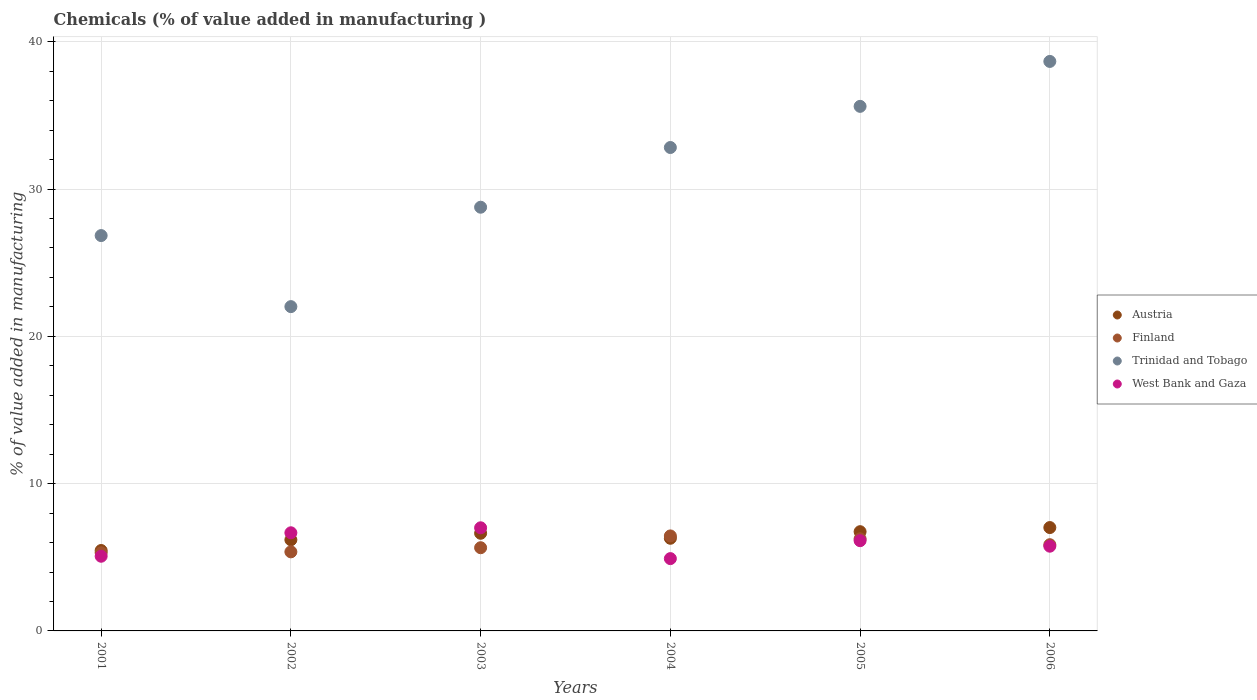How many different coloured dotlines are there?
Your answer should be very brief. 4. What is the value added in manufacturing chemicals in Finland in 2004?
Provide a succinct answer. 6.45. Across all years, what is the maximum value added in manufacturing chemicals in Finland?
Give a very brief answer. 6.45. Across all years, what is the minimum value added in manufacturing chemicals in Trinidad and Tobago?
Offer a terse response. 22.02. In which year was the value added in manufacturing chemicals in Austria maximum?
Ensure brevity in your answer.  2006. What is the total value added in manufacturing chemicals in Trinidad and Tobago in the graph?
Offer a terse response. 184.73. What is the difference between the value added in manufacturing chemicals in Austria in 2003 and that in 2006?
Keep it short and to the point. -0.39. What is the difference between the value added in manufacturing chemicals in Finland in 2005 and the value added in manufacturing chemicals in Austria in 2001?
Provide a succinct answer. 0.79. What is the average value added in manufacturing chemicals in West Bank and Gaza per year?
Keep it short and to the point. 5.92. In the year 2002, what is the difference between the value added in manufacturing chemicals in Trinidad and Tobago and value added in manufacturing chemicals in West Bank and Gaza?
Give a very brief answer. 15.36. In how many years, is the value added in manufacturing chemicals in Austria greater than 14 %?
Offer a very short reply. 0. What is the ratio of the value added in manufacturing chemicals in West Bank and Gaza in 2004 to that in 2006?
Your answer should be very brief. 0.85. What is the difference between the highest and the second highest value added in manufacturing chemicals in Finland?
Give a very brief answer. 0.2. What is the difference between the highest and the lowest value added in manufacturing chemicals in Austria?
Your answer should be compact. 1.56. In how many years, is the value added in manufacturing chemicals in Austria greater than the average value added in manufacturing chemicals in Austria taken over all years?
Offer a very short reply. 3. Is it the case that in every year, the sum of the value added in manufacturing chemicals in Trinidad and Tobago and value added in manufacturing chemicals in West Bank and Gaza  is greater than the value added in manufacturing chemicals in Finland?
Make the answer very short. Yes. Does the value added in manufacturing chemicals in Trinidad and Tobago monotonically increase over the years?
Your answer should be compact. No. Are the values on the major ticks of Y-axis written in scientific E-notation?
Give a very brief answer. No. How many legend labels are there?
Ensure brevity in your answer.  4. How are the legend labels stacked?
Provide a succinct answer. Vertical. What is the title of the graph?
Keep it short and to the point. Chemicals (% of value added in manufacturing ). Does "Other small states" appear as one of the legend labels in the graph?
Give a very brief answer. No. What is the label or title of the X-axis?
Keep it short and to the point. Years. What is the label or title of the Y-axis?
Keep it short and to the point. % of value added in manufacturing. What is the % of value added in manufacturing in Austria in 2001?
Offer a terse response. 5.46. What is the % of value added in manufacturing in Finland in 2001?
Give a very brief answer. 5.3. What is the % of value added in manufacturing in Trinidad and Tobago in 2001?
Your answer should be very brief. 26.84. What is the % of value added in manufacturing of West Bank and Gaza in 2001?
Provide a succinct answer. 5.07. What is the % of value added in manufacturing of Austria in 2002?
Make the answer very short. 6.19. What is the % of value added in manufacturing of Finland in 2002?
Ensure brevity in your answer.  5.37. What is the % of value added in manufacturing of Trinidad and Tobago in 2002?
Your answer should be very brief. 22.02. What is the % of value added in manufacturing of West Bank and Gaza in 2002?
Offer a very short reply. 6.66. What is the % of value added in manufacturing of Austria in 2003?
Make the answer very short. 6.63. What is the % of value added in manufacturing of Finland in 2003?
Your response must be concise. 5.65. What is the % of value added in manufacturing in Trinidad and Tobago in 2003?
Ensure brevity in your answer.  28.77. What is the % of value added in manufacturing in West Bank and Gaza in 2003?
Keep it short and to the point. 7. What is the % of value added in manufacturing of Austria in 2004?
Your answer should be very brief. 6.29. What is the % of value added in manufacturing in Finland in 2004?
Your response must be concise. 6.45. What is the % of value added in manufacturing in Trinidad and Tobago in 2004?
Your answer should be very brief. 32.82. What is the % of value added in manufacturing of West Bank and Gaza in 2004?
Keep it short and to the point. 4.91. What is the % of value added in manufacturing of Austria in 2005?
Give a very brief answer. 6.74. What is the % of value added in manufacturing of Finland in 2005?
Provide a succinct answer. 6.25. What is the % of value added in manufacturing of Trinidad and Tobago in 2005?
Provide a succinct answer. 35.61. What is the % of value added in manufacturing in West Bank and Gaza in 2005?
Provide a succinct answer. 6.13. What is the % of value added in manufacturing of Austria in 2006?
Give a very brief answer. 7.02. What is the % of value added in manufacturing in Finland in 2006?
Keep it short and to the point. 5.85. What is the % of value added in manufacturing of Trinidad and Tobago in 2006?
Provide a short and direct response. 38.67. What is the % of value added in manufacturing in West Bank and Gaza in 2006?
Your response must be concise. 5.75. Across all years, what is the maximum % of value added in manufacturing of Austria?
Keep it short and to the point. 7.02. Across all years, what is the maximum % of value added in manufacturing in Finland?
Keep it short and to the point. 6.45. Across all years, what is the maximum % of value added in manufacturing of Trinidad and Tobago?
Keep it short and to the point. 38.67. Across all years, what is the maximum % of value added in manufacturing in West Bank and Gaza?
Provide a succinct answer. 7. Across all years, what is the minimum % of value added in manufacturing in Austria?
Your response must be concise. 5.46. Across all years, what is the minimum % of value added in manufacturing in Finland?
Offer a terse response. 5.3. Across all years, what is the minimum % of value added in manufacturing in Trinidad and Tobago?
Provide a short and direct response. 22.02. Across all years, what is the minimum % of value added in manufacturing in West Bank and Gaza?
Provide a short and direct response. 4.91. What is the total % of value added in manufacturing of Austria in the graph?
Your response must be concise. 38.32. What is the total % of value added in manufacturing in Finland in the graph?
Offer a very short reply. 34.88. What is the total % of value added in manufacturing in Trinidad and Tobago in the graph?
Ensure brevity in your answer.  184.73. What is the total % of value added in manufacturing of West Bank and Gaza in the graph?
Your answer should be very brief. 35.52. What is the difference between the % of value added in manufacturing in Austria in 2001 and that in 2002?
Your answer should be compact. -0.73. What is the difference between the % of value added in manufacturing in Finland in 2001 and that in 2002?
Offer a terse response. -0.06. What is the difference between the % of value added in manufacturing in Trinidad and Tobago in 2001 and that in 2002?
Your response must be concise. 4.82. What is the difference between the % of value added in manufacturing of West Bank and Gaza in 2001 and that in 2002?
Your answer should be very brief. -1.59. What is the difference between the % of value added in manufacturing in Austria in 2001 and that in 2003?
Give a very brief answer. -1.17. What is the difference between the % of value added in manufacturing of Finland in 2001 and that in 2003?
Provide a succinct answer. -0.34. What is the difference between the % of value added in manufacturing in Trinidad and Tobago in 2001 and that in 2003?
Keep it short and to the point. -1.93. What is the difference between the % of value added in manufacturing of West Bank and Gaza in 2001 and that in 2003?
Offer a very short reply. -1.93. What is the difference between the % of value added in manufacturing of Austria in 2001 and that in 2004?
Your answer should be very brief. -0.83. What is the difference between the % of value added in manufacturing of Finland in 2001 and that in 2004?
Give a very brief answer. -1.15. What is the difference between the % of value added in manufacturing of Trinidad and Tobago in 2001 and that in 2004?
Ensure brevity in your answer.  -5.98. What is the difference between the % of value added in manufacturing of West Bank and Gaza in 2001 and that in 2004?
Your answer should be compact. 0.16. What is the difference between the % of value added in manufacturing in Austria in 2001 and that in 2005?
Offer a very short reply. -1.28. What is the difference between the % of value added in manufacturing of Finland in 2001 and that in 2005?
Your response must be concise. -0.95. What is the difference between the % of value added in manufacturing of Trinidad and Tobago in 2001 and that in 2005?
Give a very brief answer. -8.77. What is the difference between the % of value added in manufacturing of West Bank and Gaza in 2001 and that in 2005?
Ensure brevity in your answer.  -1.06. What is the difference between the % of value added in manufacturing of Austria in 2001 and that in 2006?
Your response must be concise. -1.56. What is the difference between the % of value added in manufacturing of Finland in 2001 and that in 2006?
Your response must be concise. -0.55. What is the difference between the % of value added in manufacturing in Trinidad and Tobago in 2001 and that in 2006?
Your response must be concise. -11.82. What is the difference between the % of value added in manufacturing in West Bank and Gaza in 2001 and that in 2006?
Your response must be concise. -0.68. What is the difference between the % of value added in manufacturing of Austria in 2002 and that in 2003?
Your answer should be compact. -0.44. What is the difference between the % of value added in manufacturing in Finland in 2002 and that in 2003?
Ensure brevity in your answer.  -0.28. What is the difference between the % of value added in manufacturing of Trinidad and Tobago in 2002 and that in 2003?
Keep it short and to the point. -6.75. What is the difference between the % of value added in manufacturing in West Bank and Gaza in 2002 and that in 2003?
Your answer should be compact. -0.34. What is the difference between the % of value added in manufacturing in Austria in 2002 and that in 2004?
Make the answer very short. -0.1. What is the difference between the % of value added in manufacturing in Finland in 2002 and that in 2004?
Ensure brevity in your answer.  -1.08. What is the difference between the % of value added in manufacturing of Trinidad and Tobago in 2002 and that in 2004?
Your response must be concise. -10.8. What is the difference between the % of value added in manufacturing of West Bank and Gaza in 2002 and that in 2004?
Give a very brief answer. 1.75. What is the difference between the % of value added in manufacturing in Austria in 2002 and that in 2005?
Your answer should be very brief. -0.55. What is the difference between the % of value added in manufacturing of Finland in 2002 and that in 2005?
Ensure brevity in your answer.  -0.89. What is the difference between the % of value added in manufacturing in Trinidad and Tobago in 2002 and that in 2005?
Offer a terse response. -13.6. What is the difference between the % of value added in manufacturing in West Bank and Gaza in 2002 and that in 2005?
Your answer should be compact. 0.54. What is the difference between the % of value added in manufacturing in Austria in 2002 and that in 2006?
Provide a succinct answer. -0.83. What is the difference between the % of value added in manufacturing of Finland in 2002 and that in 2006?
Offer a terse response. -0.49. What is the difference between the % of value added in manufacturing of Trinidad and Tobago in 2002 and that in 2006?
Keep it short and to the point. -16.65. What is the difference between the % of value added in manufacturing of West Bank and Gaza in 2002 and that in 2006?
Ensure brevity in your answer.  0.91. What is the difference between the % of value added in manufacturing of Austria in 2003 and that in 2004?
Your answer should be compact. 0.34. What is the difference between the % of value added in manufacturing in Finland in 2003 and that in 2004?
Your response must be concise. -0.8. What is the difference between the % of value added in manufacturing in Trinidad and Tobago in 2003 and that in 2004?
Provide a succinct answer. -4.05. What is the difference between the % of value added in manufacturing in West Bank and Gaza in 2003 and that in 2004?
Keep it short and to the point. 2.09. What is the difference between the % of value added in manufacturing in Austria in 2003 and that in 2005?
Provide a succinct answer. -0.11. What is the difference between the % of value added in manufacturing of Finland in 2003 and that in 2005?
Ensure brevity in your answer.  -0.6. What is the difference between the % of value added in manufacturing in Trinidad and Tobago in 2003 and that in 2005?
Offer a very short reply. -6.85. What is the difference between the % of value added in manufacturing of West Bank and Gaza in 2003 and that in 2005?
Your response must be concise. 0.87. What is the difference between the % of value added in manufacturing of Austria in 2003 and that in 2006?
Your answer should be very brief. -0.39. What is the difference between the % of value added in manufacturing of Finland in 2003 and that in 2006?
Provide a succinct answer. -0.2. What is the difference between the % of value added in manufacturing of Trinidad and Tobago in 2003 and that in 2006?
Provide a short and direct response. -9.9. What is the difference between the % of value added in manufacturing of West Bank and Gaza in 2003 and that in 2006?
Your answer should be very brief. 1.25. What is the difference between the % of value added in manufacturing of Austria in 2004 and that in 2005?
Your answer should be compact. -0.45. What is the difference between the % of value added in manufacturing in Finland in 2004 and that in 2005?
Provide a succinct answer. 0.2. What is the difference between the % of value added in manufacturing in Trinidad and Tobago in 2004 and that in 2005?
Your answer should be very brief. -2.79. What is the difference between the % of value added in manufacturing in West Bank and Gaza in 2004 and that in 2005?
Offer a terse response. -1.22. What is the difference between the % of value added in manufacturing in Austria in 2004 and that in 2006?
Your answer should be compact. -0.73. What is the difference between the % of value added in manufacturing in Finland in 2004 and that in 2006?
Give a very brief answer. 0.6. What is the difference between the % of value added in manufacturing of Trinidad and Tobago in 2004 and that in 2006?
Provide a short and direct response. -5.84. What is the difference between the % of value added in manufacturing in West Bank and Gaza in 2004 and that in 2006?
Keep it short and to the point. -0.84. What is the difference between the % of value added in manufacturing in Austria in 2005 and that in 2006?
Offer a very short reply. -0.28. What is the difference between the % of value added in manufacturing of Finland in 2005 and that in 2006?
Keep it short and to the point. 0.4. What is the difference between the % of value added in manufacturing of Trinidad and Tobago in 2005 and that in 2006?
Your response must be concise. -3.05. What is the difference between the % of value added in manufacturing in West Bank and Gaza in 2005 and that in 2006?
Offer a terse response. 0.37. What is the difference between the % of value added in manufacturing in Austria in 2001 and the % of value added in manufacturing in Finland in 2002?
Make the answer very short. 0.09. What is the difference between the % of value added in manufacturing of Austria in 2001 and the % of value added in manufacturing of Trinidad and Tobago in 2002?
Your answer should be very brief. -16.56. What is the difference between the % of value added in manufacturing of Austria in 2001 and the % of value added in manufacturing of West Bank and Gaza in 2002?
Your response must be concise. -1.2. What is the difference between the % of value added in manufacturing of Finland in 2001 and the % of value added in manufacturing of Trinidad and Tobago in 2002?
Keep it short and to the point. -16.71. What is the difference between the % of value added in manufacturing of Finland in 2001 and the % of value added in manufacturing of West Bank and Gaza in 2002?
Your answer should be compact. -1.36. What is the difference between the % of value added in manufacturing in Trinidad and Tobago in 2001 and the % of value added in manufacturing in West Bank and Gaza in 2002?
Ensure brevity in your answer.  20.18. What is the difference between the % of value added in manufacturing in Austria in 2001 and the % of value added in manufacturing in Finland in 2003?
Make the answer very short. -0.19. What is the difference between the % of value added in manufacturing in Austria in 2001 and the % of value added in manufacturing in Trinidad and Tobago in 2003?
Ensure brevity in your answer.  -23.31. What is the difference between the % of value added in manufacturing of Austria in 2001 and the % of value added in manufacturing of West Bank and Gaza in 2003?
Provide a short and direct response. -1.54. What is the difference between the % of value added in manufacturing in Finland in 2001 and the % of value added in manufacturing in Trinidad and Tobago in 2003?
Offer a very short reply. -23.46. What is the difference between the % of value added in manufacturing of Finland in 2001 and the % of value added in manufacturing of West Bank and Gaza in 2003?
Make the answer very short. -1.7. What is the difference between the % of value added in manufacturing in Trinidad and Tobago in 2001 and the % of value added in manufacturing in West Bank and Gaza in 2003?
Offer a very short reply. 19.84. What is the difference between the % of value added in manufacturing in Austria in 2001 and the % of value added in manufacturing in Finland in 2004?
Your answer should be compact. -0.99. What is the difference between the % of value added in manufacturing in Austria in 2001 and the % of value added in manufacturing in Trinidad and Tobago in 2004?
Your answer should be very brief. -27.36. What is the difference between the % of value added in manufacturing in Austria in 2001 and the % of value added in manufacturing in West Bank and Gaza in 2004?
Offer a very short reply. 0.55. What is the difference between the % of value added in manufacturing of Finland in 2001 and the % of value added in manufacturing of Trinidad and Tobago in 2004?
Your answer should be compact. -27.52. What is the difference between the % of value added in manufacturing in Finland in 2001 and the % of value added in manufacturing in West Bank and Gaza in 2004?
Your response must be concise. 0.39. What is the difference between the % of value added in manufacturing in Trinidad and Tobago in 2001 and the % of value added in manufacturing in West Bank and Gaza in 2004?
Provide a succinct answer. 21.93. What is the difference between the % of value added in manufacturing of Austria in 2001 and the % of value added in manufacturing of Finland in 2005?
Offer a terse response. -0.79. What is the difference between the % of value added in manufacturing of Austria in 2001 and the % of value added in manufacturing of Trinidad and Tobago in 2005?
Ensure brevity in your answer.  -30.15. What is the difference between the % of value added in manufacturing of Austria in 2001 and the % of value added in manufacturing of West Bank and Gaza in 2005?
Ensure brevity in your answer.  -0.67. What is the difference between the % of value added in manufacturing of Finland in 2001 and the % of value added in manufacturing of Trinidad and Tobago in 2005?
Offer a terse response. -30.31. What is the difference between the % of value added in manufacturing of Finland in 2001 and the % of value added in manufacturing of West Bank and Gaza in 2005?
Your response must be concise. -0.82. What is the difference between the % of value added in manufacturing of Trinidad and Tobago in 2001 and the % of value added in manufacturing of West Bank and Gaza in 2005?
Ensure brevity in your answer.  20.71. What is the difference between the % of value added in manufacturing in Austria in 2001 and the % of value added in manufacturing in Finland in 2006?
Your answer should be compact. -0.39. What is the difference between the % of value added in manufacturing in Austria in 2001 and the % of value added in manufacturing in Trinidad and Tobago in 2006?
Your answer should be compact. -33.2. What is the difference between the % of value added in manufacturing in Austria in 2001 and the % of value added in manufacturing in West Bank and Gaza in 2006?
Your response must be concise. -0.29. What is the difference between the % of value added in manufacturing of Finland in 2001 and the % of value added in manufacturing of Trinidad and Tobago in 2006?
Your answer should be compact. -33.36. What is the difference between the % of value added in manufacturing in Finland in 2001 and the % of value added in manufacturing in West Bank and Gaza in 2006?
Offer a very short reply. -0.45. What is the difference between the % of value added in manufacturing in Trinidad and Tobago in 2001 and the % of value added in manufacturing in West Bank and Gaza in 2006?
Give a very brief answer. 21.09. What is the difference between the % of value added in manufacturing of Austria in 2002 and the % of value added in manufacturing of Finland in 2003?
Your answer should be compact. 0.54. What is the difference between the % of value added in manufacturing of Austria in 2002 and the % of value added in manufacturing of Trinidad and Tobago in 2003?
Keep it short and to the point. -22.58. What is the difference between the % of value added in manufacturing of Austria in 2002 and the % of value added in manufacturing of West Bank and Gaza in 2003?
Your answer should be very brief. -0.81. What is the difference between the % of value added in manufacturing in Finland in 2002 and the % of value added in manufacturing in Trinidad and Tobago in 2003?
Make the answer very short. -23.4. What is the difference between the % of value added in manufacturing in Finland in 2002 and the % of value added in manufacturing in West Bank and Gaza in 2003?
Your answer should be compact. -1.63. What is the difference between the % of value added in manufacturing in Trinidad and Tobago in 2002 and the % of value added in manufacturing in West Bank and Gaza in 2003?
Give a very brief answer. 15.02. What is the difference between the % of value added in manufacturing in Austria in 2002 and the % of value added in manufacturing in Finland in 2004?
Your answer should be compact. -0.26. What is the difference between the % of value added in manufacturing in Austria in 2002 and the % of value added in manufacturing in Trinidad and Tobago in 2004?
Your answer should be compact. -26.63. What is the difference between the % of value added in manufacturing in Austria in 2002 and the % of value added in manufacturing in West Bank and Gaza in 2004?
Keep it short and to the point. 1.28. What is the difference between the % of value added in manufacturing of Finland in 2002 and the % of value added in manufacturing of Trinidad and Tobago in 2004?
Your response must be concise. -27.45. What is the difference between the % of value added in manufacturing in Finland in 2002 and the % of value added in manufacturing in West Bank and Gaza in 2004?
Your answer should be very brief. 0.46. What is the difference between the % of value added in manufacturing in Trinidad and Tobago in 2002 and the % of value added in manufacturing in West Bank and Gaza in 2004?
Offer a terse response. 17.11. What is the difference between the % of value added in manufacturing of Austria in 2002 and the % of value added in manufacturing of Finland in 2005?
Provide a short and direct response. -0.07. What is the difference between the % of value added in manufacturing of Austria in 2002 and the % of value added in manufacturing of Trinidad and Tobago in 2005?
Your response must be concise. -29.43. What is the difference between the % of value added in manufacturing of Austria in 2002 and the % of value added in manufacturing of West Bank and Gaza in 2005?
Keep it short and to the point. 0.06. What is the difference between the % of value added in manufacturing of Finland in 2002 and the % of value added in manufacturing of Trinidad and Tobago in 2005?
Ensure brevity in your answer.  -30.25. What is the difference between the % of value added in manufacturing in Finland in 2002 and the % of value added in manufacturing in West Bank and Gaza in 2005?
Offer a terse response. -0.76. What is the difference between the % of value added in manufacturing in Trinidad and Tobago in 2002 and the % of value added in manufacturing in West Bank and Gaza in 2005?
Offer a very short reply. 15.89. What is the difference between the % of value added in manufacturing in Austria in 2002 and the % of value added in manufacturing in Finland in 2006?
Offer a very short reply. 0.33. What is the difference between the % of value added in manufacturing in Austria in 2002 and the % of value added in manufacturing in Trinidad and Tobago in 2006?
Offer a very short reply. -32.48. What is the difference between the % of value added in manufacturing in Austria in 2002 and the % of value added in manufacturing in West Bank and Gaza in 2006?
Ensure brevity in your answer.  0.43. What is the difference between the % of value added in manufacturing in Finland in 2002 and the % of value added in manufacturing in Trinidad and Tobago in 2006?
Give a very brief answer. -33.3. What is the difference between the % of value added in manufacturing in Finland in 2002 and the % of value added in manufacturing in West Bank and Gaza in 2006?
Offer a terse response. -0.38. What is the difference between the % of value added in manufacturing in Trinidad and Tobago in 2002 and the % of value added in manufacturing in West Bank and Gaza in 2006?
Give a very brief answer. 16.27. What is the difference between the % of value added in manufacturing of Austria in 2003 and the % of value added in manufacturing of Finland in 2004?
Keep it short and to the point. 0.18. What is the difference between the % of value added in manufacturing of Austria in 2003 and the % of value added in manufacturing of Trinidad and Tobago in 2004?
Your answer should be very brief. -26.19. What is the difference between the % of value added in manufacturing of Austria in 2003 and the % of value added in manufacturing of West Bank and Gaza in 2004?
Make the answer very short. 1.72. What is the difference between the % of value added in manufacturing in Finland in 2003 and the % of value added in manufacturing in Trinidad and Tobago in 2004?
Provide a short and direct response. -27.17. What is the difference between the % of value added in manufacturing of Finland in 2003 and the % of value added in manufacturing of West Bank and Gaza in 2004?
Provide a short and direct response. 0.74. What is the difference between the % of value added in manufacturing in Trinidad and Tobago in 2003 and the % of value added in manufacturing in West Bank and Gaza in 2004?
Provide a short and direct response. 23.86. What is the difference between the % of value added in manufacturing of Austria in 2003 and the % of value added in manufacturing of Finland in 2005?
Keep it short and to the point. 0.38. What is the difference between the % of value added in manufacturing of Austria in 2003 and the % of value added in manufacturing of Trinidad and Tobago in 2005?
Provide a short and direct response. -28.99. What is the difference between the % of value added in manufacturing in Austria in 2003 and the % of value added in manufacturing in West Bank and Gaza in 2005?
Offer a very short reply. 0.5. What is the difference between the % of value added in manufacturing in Finland in 2003 and the % of value added in manufacturing in Trinidad and Tobago in 2005?
Provide a short and direct response. -29.97. What is the difference between the % of value added in manufacturing of Finland in 2003 and the % of value added in manufacturing of West Bank and Gaza in 2005?
Offer a very short reply. -0.48. What is the difference between the % of value added in manufacturing in Trinidad and Tobago in 2003 and the % of value added in manufacturing in West Bank and Gaza in 2005?
Give a very brief answer. 22.64. What is the difference between the % of value added in manufacturing of Austria in 2003 and the % of value added in manufacturing of Finland in 2006?
Keep it short and to the point. 0.78. What is the difference between the % of value added in manufacturing of Austria in 2003 and the % of value added in manufacturing of Trinidad and Tobago in 2006?
Provide a succinct answer. -32.04. What is the difference between the % of value added in manufacturing in Austria in 2003 and the % of value added in manufacturing in West Bank and Gaza in 2006?
Make the answer very short. 0.88. What is the difference between the % of value added in manufacturing in Finland in 2003 and the % of value added in manufacturing in Trinidad and Tobago in 2006?
Your answer should be compact. -33.02. What is the difference between the % of value added in manufacturing in Finland in 2003 and the % of value added in manufacturing in West Bank and Gaza in 2006?
Provide a succinct answer. -0.1. What is the difference between the % of value added in manufacturing of Trinidad and Tobago in 2003 and the % of value added in manufacturing of West Bank and Gaza in 2006?
Offer a very short reply. 23.01. What is the difference between the % of value added in manufacturing in Austria in 2004 and the % of value added in manufacturing in Finland in 2005?
Your answer should be very brief. 0.04. What is the difference between the % of value added in manufacturing in Austria in 2004 and the % of value added in manufacturing in Trinidad and Tobago in 2005?
Provide a succinct answer. -29.32. What is the difference between the % of value added in manufacturing in Austria in 2004 and the % of value added in manufacturing in West Bank and Gaza in 2005?
Give a very brief answer. 0.16. What is the difference between the % of value added in manufacturing in Finland in 2004 and the % of value added in manufacturing in Trinidad and Tobago in 2005?
Make the answer very short. -29.17. What is the difference between the % of value added in manufacturing in Finland in 2004 and the % of value added in manufacturing in West Bank and Gaza in 2005?
Offer a very short reply. 0.32. What is the difference between the % of value added in manufacturing in Trinidad and Tobago in 2004 and the % of value added in manufacturing in West Bank and Gaza in 2005?
Offer a very short reply. 26.69. What is the difference between the % of value added in manufacturing in Austria in 2004 and the % of value added in manufacturing in Finland in 2006?
Provide a succinct answer. 0.44. What is the difference between the % of value added in manufacturing of Austria in 2004 and the % of value added in manufacturing of Trinidad and Tobago in 2006?
Your answer should be very brief. -32.38. What is the difference between the % of value added in manufacturing in Austria in 2004 and the % of value added in manufacturing in West Bank and Gaza in 2006?
Give a very brief answer. 0.54. What is the difference between the % of value added in manufacturing in Finland in 2004 and the % of value added in manufacturing in Trinidad and Tobago in 2006?
Provide a succinct answer. -32.22. What is the difference between the % of value added in manufacturing of Finland in 2004 and the % of value added in manufacturing of West Bank and Gaza in 2006?
Your response must be concise. 0.7. What is the difference between the % of value added in manufacturing of Trinidad and Tobago in 2004 and the % of value added in manufacturing of West Bank and Gaza in 2006?
Ensure brevity in your answer.  27.07. What is the difference between the % of value added in manufacturing of Austria in 2005 and the % of value added in manufacturing of Finland in 2006?
Give a very brief answer. 0.88. What is the difference between the % of value added in manufacturing of Austria in 2005 and the % of value added in manufacturing of Trinidad and Tobago in 2006?
Make the answer very short. -31.93. What is the difference between the % of value added in manufacturing of Austria in 2005 and the % of value added in manufacturing of West Bank and Gaza in 2006?
Offer a very short reply. 0.99. What is the difference between the % of value added in manufacturing of Finland in 2005 and the % of value added in manufacturing of Trinidad and Tobago in 2006?
Provide a succinct answer. -32.41. What is the difference between the % of value added in manufacturing of Finland in 2005 and the % of value added in manufacturing of West Bank and Gaza in 2006?
Provide a short and direct response. 0.5. What is the difference between the % of value added in manufacturing of Trinidad and Tobago in 2005 and the % of value added in manufacturing of West Bank and Gaza in 2006?
Ensure brevity in your answer.  29.86. What is the average % of value added in manufacturing of Austria per year?
Ensure brevity in your answer.  6.39. What is the average % of value added in manufacturing of Finland per year?
Your answer should be very brief. 5.81. What is the average % of value added in manufacturing in Trinidad and Tobago per year?
Offer a very short reply. 30.79. What is the average % of value added in manufacturing in West Bank and Gaza per year?
Offer a very short reply. 5.92. In the year 2001, what is the difference between the % of value added in manufacturing in Austria and % of value added in manufacturing in Finland?
Make the answer very short. 0.16. In the year 2001, what is the difference between the % of value added in manufacturing in Austria and % of value added in manufacturing in Trinidad and Tobago?
Offer a terse response. -21.38. In the year 2001, what is the difference between the % of value added in manufacturing of Austria and % of value added in manufacturing of West Bank and Gaza?
Make the answer very short. 0.39. In the year 2001, what is the difference between the % of value added in manufacturing of Finland and % of value added in manufacturing of Trinidad and Tobago?
Your answer should be very brief. -21.54. In the year 2001, what is the difference between the % of value added in manufacturing in Finland and % of value added in manufacturing in West Bank and Gaza?
Your answer should be compact. 0.23. In the year 2001, what is the difference between the % of value added in manufacturing in Trinidad and Tobago and % of value added in manufacturing in West Bank and Gaza?
Provide a short and direct response. 21.77. In the year 2002, what is the difference between the % of value added in manufacturing of Austria and % of value added in manufacturing of Finland?
Offer a very short reply. 0.82. In the year 2002, what is the difference between the % of value added in manufacturing of Austria and % of value added in manufacturing of Trinidad and Tobago?
Keep it short and to the point. -15.83. In the year 2002, what is the difference between the % of value added in manufacturing of Austria and % of value added in manufacturing of West Bank and Gaza?
Offer a terse response. -0.48. In the year 2002, what is the difference between the % of value added in manufacturing in Finland and % of value added in manufacturing in Trinidad and Tobago?
Keep it short and to the point. -16.65. In the year 2002, what is the difference between the % of value added in manufacturing in Finland and % of value added in manufacturing in West Bank and Gaza?
Offer a very short reply. -1.29. In the year 2002, what is the difference between the % of value added in manufacturing of Trinidad and Tobago and % of value added in manufacturing of West Bank and Gaza?
Your answer should be compact. 15.36. In the year 2003, what is the difference between the % of value added in manufacturing in Austria and % of value added in manufacturing in Finland?
Provide a succinct answer. 0.98. In the year 2003, what is the difference between the % of value added in manufacturing in Austria and % of value added in manufacturing in Trinidad and Tobago?
Offer a terse response. -22.14. In the year 2003, what is the difference between the % of value added in manufacturing in Austria and % of value added in manufacturing in West Bank and Gaza?
Provide a succinct answer. -0.37. In the year 2003, what is the difference between the % of value added in manufacturing in Finland and % of value added in manufacturing in Trinidad and Tobago?
Keep it short and to the point. -23.12. In the year 2003, what is the difference between the % of value added in manufacturing of Finland and % of value added in manufacturing of West Bank and Gaza?
Your response must be concise. -1.35. In the year 2003, what is the difference between the % of value added in manufacturing in Trinidad and Tobago and % of value added in manufacturing in West Bank and Gaza?
Offer a terse response. 21.77. In the year 2004, what is the difference between the % of value added in manufacturing of Austria and % of value added in manufacturing of Finland?
Keep it short and to the point. -0.16. In the year 2004, what is the difference between the % of value added in manufacturing of Austria and % of value added in manufacturing of Trinidad and Tobago?
Keep it short and to the point. -26.53. In the year 2004, what is the difference between the % of value added in manufacturing in Austria and % of value added in manufacturing in West Bank and Gaza?
Give a very brief answer. 1.38. In the year 2004, what is the difference between the % of value added in manufacturing in Finland and % of value added in manufacturing in Trinidad and Tobago?
Offer a very short reply. -26.37. In the year 2004, what is the difference between the % of value added in manufacturing of Finland and % of value added in manufacturing of West Bank and Gaza?
Your answer should be very brief. 1.54. In the year 2004, what is the difference between the % of value added in manufacturing in Trinidad and Tobago and % of value added in manufacturing in West Bank and Gaza?
Make the answer very short. 27.91. In the year 2005, what is the difference between the % of value added in manufacturing of Austria and % of value added in manufacturing of Finland?
Give a very brief answer. 0.48. In the year 2005, what is the difference between the % of value added in manufacturing of Austria and % of value added in manufacturing of Trinidad and Tobago?
Keep it short and to the point. -28.88. In the year 2005, what is the difference between the % of value added in manufacturing in Austria and % of value added in manufacturing in West Bank and Gaza?
Offer a very short reply. 0.61. In the year 2005, what is the difference between the % of value added in manufacturing in Finland and % of value added in manufacturing in Trinidad and Tobago?
Give a very brief answer. -29.36. In the year 2005, what is the difference between the % of value added in manufacturing of Finland and % of value added in manufacturing of West Bank and Gaza?
Offer a very short reply. 0.13. In the year 2005, what is the difference between the % of value added in manufacturing of Trinidad and Tobago and % of value added in manufacturing of West Bank and Gaza?
Your response must be concise. 29.49. In the year 2006, what is the difference between the % of value added in manufacturing in Austria and % of value added in manufacturing in Finland?
Your answer should be very brief. 1.16. In the year 2006, what is the difference between the % of value added in manufacturing in Austria and % of value added in manufacturing in Trinidad and Tobago?
Ensure brevity in your answer.  -31.65. In the year 2006, what is the difference between the % of value added in manufacturing of Austria and % of value added in manufacturing of West Bank and Gaza?
Ensure brevity in your answer.  1.27. In the year 2006, what is the difference between the % of value added in manufacturing of Finland and % of value added in manufacturing of Trinidad and Tobago?
Provide a succinct answer. -32.81. In the year 2006, what is the difference between the % of value added in manufacturing in Finland and % of value added in manufacturing in West Bank and Gaza?
Offer a terse response. 0.1. In the year 2006, what is the difference between the % of value added in manufacturing of Trinidad and Tobago and % of value added in manufacturing of West Bank and Gaza?
Give a very brief answer. 32.91. What is the ratio of the % of value added in manufacturing of Austria in 2001 to that in 2002?
Your response must be concise. 0.88. What is the ratio of the % of value added in manufacturing in Finland in 2001 to that in 2002?
Make the answer very short. 0.99. What is the ratio of the % of value added in manufacturing in Trinidad and Tobago in 2001 to that in 2002?
Your answer should be compact. 1.22. What is the ratio of the % of value added in manufacturing of West Bank and Gaza in 2001 to that in 2002?
Your response must be concise. 0.76. What is the ratio of the % of value added in manufacturing of Austria in 2001 to that in 2003?
Ensure brevity in your answer.  0.82. What is the ratio of the % of value added in manufacturing of Finland in 2001 to that in 2003?
Your answer should be compact. 0.94. What is the ratio of the % of value added in manufacturing in Trinidad and Tobago in 2001 to that in 2003?
Your answer should be very brief. 0.93. What is the ratio of the % of value added in manufacturing in West Bank and Gaza in 2001 to that in 2003?
Keep it short and to the point. 0.72. What is the ratio of the % of value added in manufacturing in Austria in 2001 to that in 2004?
Ensure brevity in your answer.  0.87. What is the ratio of the % of value added in manufacturing of Finland in 2001 to that in 2004?
Your response must be concise. 0.82. What is the ratio of the % of value added in manufacturing of Trinidad and Tobago in 2001 to that in 2004?
Keep it short and to the point. 0.82. What is the ratio of the % of value added in manufacturing of West Bank and Gaza in 2001 to that in 2004?
Your response must be concise. 1.03. What is the ratio of the % of value added in manufacturing of Austria in 2001 to that in 2005?
Make the answer very short. 0.81. What is the ratio of the % of value added in manufacturing in Finland in 2001 to that in 2005?
Offer a terse response. 0.85. What is the ratio of the % of value added in manufacturing in Trinidad and Tobago in 2001 to that in 2005?
Your answer should be compact. 0.75. What is the ratio of the % of value added in manufacturing of West Bank and Gaza in 2001 to that in 2005?
Give a very brief answer. 0.83. What is the ratio of the % of value added in manufacturing in Austria in 2001 to that in 2006?
Offer a very short reply. 0.78. What is the ratio of the % of value added in manufacturing of Finland in 2001 to that in 2006?
Ensure brevity in your answer.  0.91. What is the ratio of the % of value added in manufacturing of Trinidad and Tobago in 2001 to that in 2006?
Give a very brief answer. 0.69. What is the ratio of the % of value added in manufacturing in West Bank and Gaza in 2001 to that in 2006?
Your answer should be compact. 0.88. What is the ratio of the % of value added in manufacturing of Austria in 2002 to that in 2003?
Offer a terse response. 0.93. What is the ratio of the % of value added in manufacturing of Finland in 2002 to that in 2003?
Your response must be concise. 0.95. What is the ratio of the % of value added in manufacturing in Trinidad and Tobago in 2002 to that in 2003?
Your answer should be compact. 0.77. What is the ratio of the % of value added in manufacturing in West Bank and Gaza in 2002 to that in 2003?
Keep it short and to the point. 0.95. What is the ratio of the % of value added in manufacturing of Austria in 2002 to that in 2004?
Keep it short and to the point. 0.98. What is the ratio of the % of value added in manufacturing in Finland in 2002 to that in 2004?
Your response must be concise. 0.83. What is the ratio of the % of value added in manufacturing in Trinidad and Tobago in 2002 to that in 2004?
Keep it short and to the point. 0.67. What is the ratio of the % of value added in manufacturing of West Bank and Gaza in 2002 to that in 2004?
Provide a succinct answer. 1.36. What is the ratio of the % of value added in manufacturing in Austria in 2002 to that in 2005?
Your answer should be compact. 0.92. What is the ratio of the % of value added in manufacturing of Finland in 2002 to that in 2005?
Your answer should be compact. 0.86. What is the ratio of the % of value added in manufacturing of Trinidad and Tobago in 2002 to that in 2005?
Your response must be concise. 0.62. What is the ratio of the % of value added in manufacturing of West Bank and Gaza in 2002 to that in 2005?
Keep it short and to the point. 1.09. What is the ratio of the % of value added in manufacturing of Austria in 2002 to that in 2006?
Give a very brief answer. 0.88. What is the ratio of the % of value added in manufacturing of Finland in 2002 to that in 2006?
Your response must be concise. 0.92. What is the ratio of the % of value added in manufacturing in Trinidad and Tobago in 2002 to that in 2006?
Provide a short and direct response. 0.57. What is the ratio of the % of value added in manufacturing of West Bank and Gaza in 2002 to that in 2006?
Provide a short and direct response. 1.16. What is the ratio of the % of value added in manufacturing in Austria in 2003 to that in 2004?
Offer a very short reply. 1.05. What is the ratio of the % of value added in manufacturing in Finland in 2003 to that in 2004?
Your answer should be compact. 0.88. What is the ratio of the % of value added in manufacturing in Trinidad and Tobago in 2003 to that in 2004?
Offer a terse response. 0.88. What is the ratio of the % of value added in manufacturing of West Bank and Gaza in 2003 to that in 2004?
Make the answer very short. 1.43. What is the ratio of the % of value added in manufacturing in Austria in 2003 to that in 2005?
Your answer should be compact. 0.98. What is the ratio of the % of value added in manufacturing in Finland in 2003 to that in 2005?
Ensure brevity in your answer.  0.9. What is the ratio of the % of value added in manufacturing in Trinidad and Tobago in 2003 to that in 2005?
Keep it short and to the point. 0.81. What is the ratio of the % of value added in manufacturing in West Bank and Gaza in 2003 to that in 2005?
Your answer should be very brief. 1.14. What is the ratio of the % of value added in manufacturing in Austria in 2003 to that in 2006?
Your response must be concise. 0.94. What is the ratio of the % of value added in manufacturing in Trinidad and Tobago in 2003 to that in 2006?
Offer a terse response. 0.74. What is the ratio of the % of value added in manufacturing in West Bank and Gaza in 2003 to that in 2006?
Your response must be concise. 1.22. What is the ratio of the % of value added in manufacturing of Austria in 2004 to that in 2005?
Offer a very short reply. 0.93. What is the ratio of the % of value added in manufacturing of Finland in 2004 to that in 2005?
Your answer should be compact. 1.03. What is the ratio of the % of value added in manufacturing of Trinidad and Tobago in 2004 to that in 2005?
Keep it short and to the point. 0.92. What is the ratio of the % of value added in manufacturing in West Bank and Gaza in 2004 to that in 2005?
Keep it short and to the point. 0.8. What is the ratio of the % of value added in manufacturing in Austria in 2004 to that in 2006?
Ensure brevity in your answer.  0.9. What is the ratio of the % of value added in manufacturing of Finland in 2004 to that in 2006?
Your response must be concise. 1.1. What is the ratio of the % of value added in manufacturing in Trinidad and Tobago in 2004 to that in 2006?
Your answer should be compact. 0.85. What is the ratio of the % of value added in manufacturing of West Bank and Gaza in 2004 to that in 2006?
Offer a terse response. 0.85. What is the ratio of the % of value added in manufacturing of Austria in 2005 to that in 2006?
Your answer should be compact. 0.96. What is the ratio of the % of value added in manufacturing in Finland in 2005 to that in 2006?
Offer a terse response. 1.07. What is the ratio of the % of value added in manufacturing in Trinidad and Tobago in 2005 to that in 2006?
Offer a terse response. 0.92. What is the ratio of the % of value added in manufacturing of West Bank and Gaza in 2005 to that in 2006?
Give a very brief answer. 1.06. What is the difference between the highest and the second highest % of value added in manufacturing in Austria?
Provide a succinct answer. 0.28. What is the difference between the highest and the second highest % of value added in manufacturing in Finland?
Give a very brief answer. 0.2. What is the difference between the highest and the second highest % of value added in manufacturing in Trinidad and Tobago?
Ensure brevity in your answer.  3.05. What is the difference between the highest and the second highest % of value added in manufacturing in West Bank and Gaza?
Offer a very short reply. 0.34. What is the difference between the highest and the lowest % of value added in manufacturing of Austria?
Your answer should be compact. 1.56. What is the difference between the highest and the lowest % of value added in manufacturing of Finland?
Offer a very short reply. 1.15. What is the difference between the highest and the lowest % of value added in manufacturing of Trinidad and Tobago?
Your answer should be compact. 16.65. What is the difference between the highest and the lowest % of value added in manufacturing of West Bank and Gaza?
Your response must be concise. 2.09. 